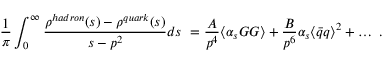<formula> <loc_0><loc_0><loc_500><loc_500>\frac { 1 } \pi } \int _ { 0 } ^ { \infty } { \frac { \rho ^ { h a d r o n } ( s ) - \rho ^ { q u a r k } ( s ) } { s - p ^ { 2 } } } d s \ = \frac { A } { p ^ { 4 } } \langle \alpha _ { s } G G \rangle + \frac { B } { p ^ { 6 } } \alpha _ { s } \langle \bar { q } q \rangle ^ { 2 } + \dots \ .</formula> 